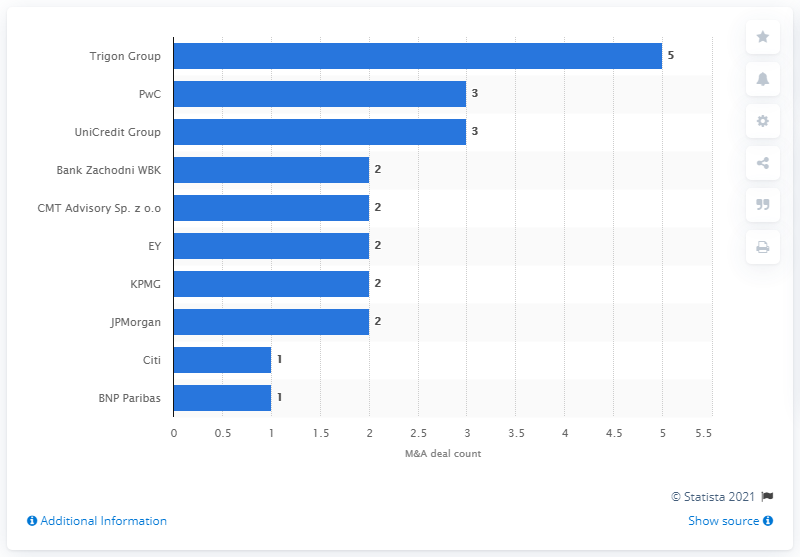Indicate a few pertinent items in this graphic. Trigon Group was named the leading advisor to mergers and acquisitions deals in Poland during the first half of 2018. 